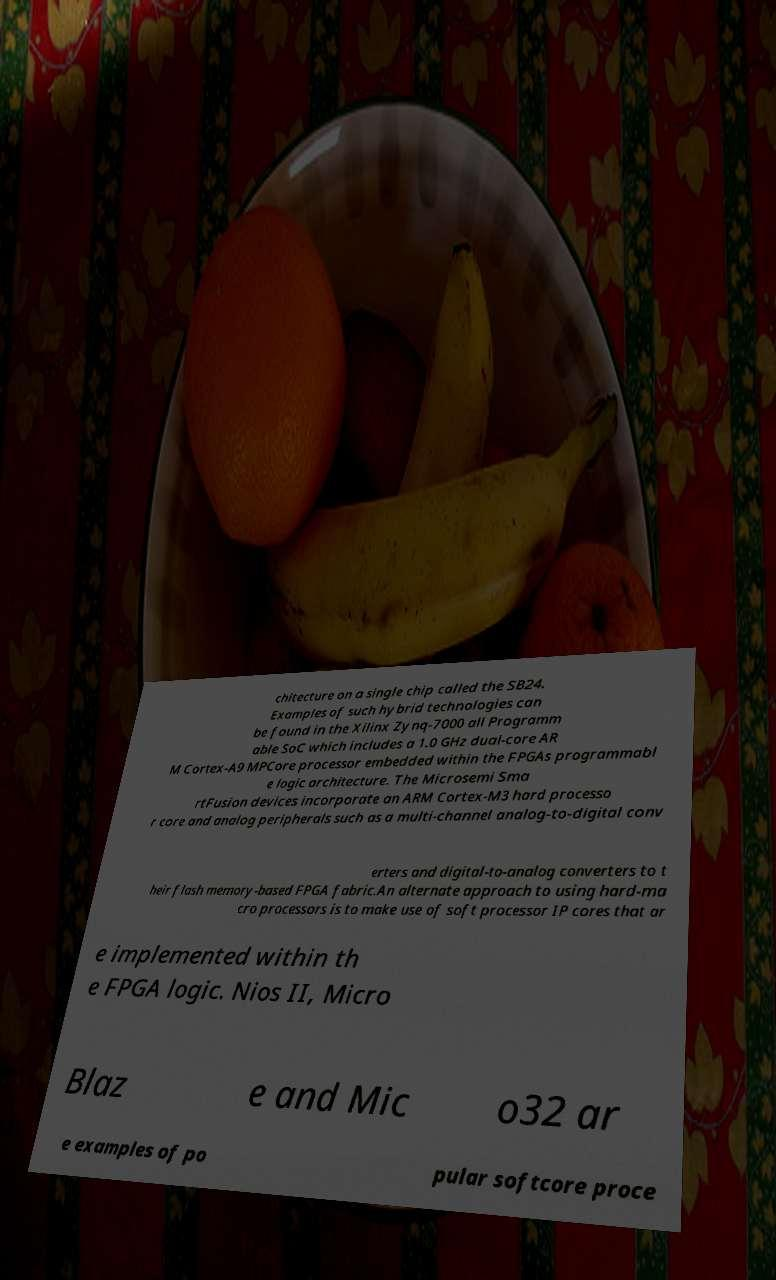What messages or text are displayed in this image? I need them in a readable, typed format. chitecture on a single chip called the SB24. Examples of such hybrid technologies can be found in the Xilinx Zynq-7000 all Programm able SoC which includes a 1.0 GHz dual-core AR M Cortex-A9 MPCore processor embedded within the FPGAs programmabl e logic architecture. The Microsemi Sma rtFusion devices incorporate an ARM Cortex-M3 hard processo r core and analog peripherals such as a multi-channel analog-to-digital conv erters and digital-to-analog converters to t heir flash memory-based FPGA fabric.An alternate approach to using hard-ma cro processors is to make use of soft processor IP cores that ar e implemented within th e FPGA logic. Nios II, Micro Blaz e and Mic o32 ar e examples of po pular softcore proce 